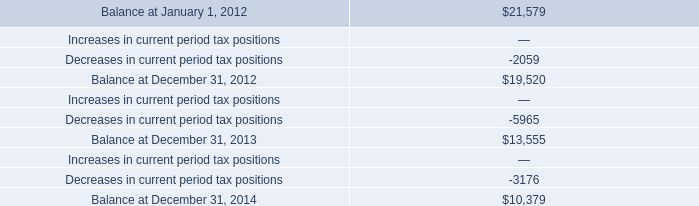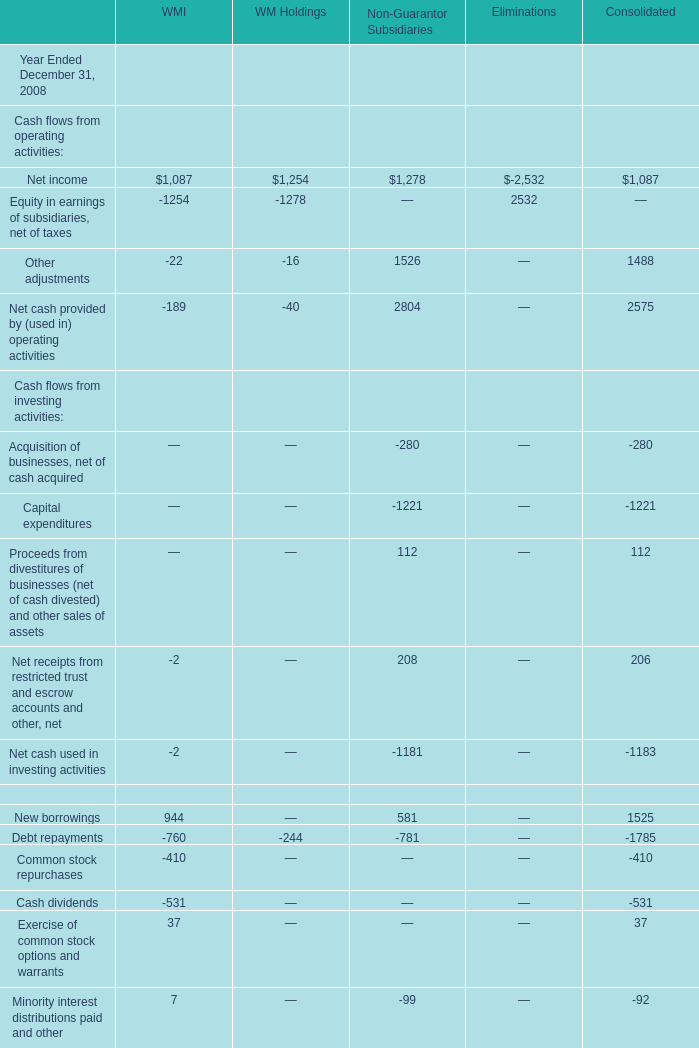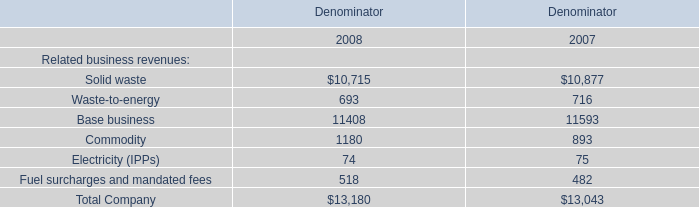What is the growing rate of Commodity in Table 2 in the year with the most Other adjustments of Non-Guarantor Subsidiaries in Table 1? 
Computations: ((1180 - 893) / 893)
Answer: 0.32139. 